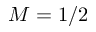Convert formula to latex. <formula><loc_0><loc_0><loc_500><loc_500>M = 1 / 2</formula> 